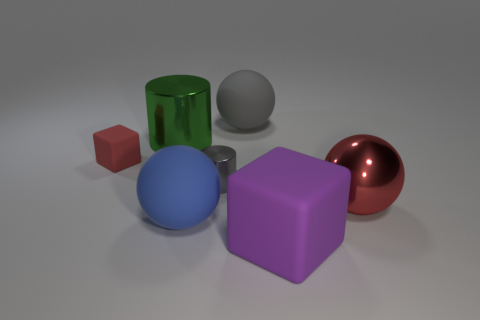Are there any gray spheres of the same size as the gray shiny cylinder?
Give a very brief answer. No. Is the material of the green object the same as the red object right of the purple thing?
Keep it short and to the point. Yes. Are there more purple rubber things than tiny cyan blocks?
Offer a very short reply. Yes. How many balls are big purple matte objects or large green shiny objects?
Provide a succinct answer. 0. The big cube has what color?
Ensure brevity in your answer.  Purple. Does the gray object behind the big green cylinder have the same size as the metal thing in front of the small cylinder?
Your response must be concise. Yes. Are there fewer blue rubber spheres than green matte cylinders?
Offer a terse response. No. What number of cylinders are in front of the tiny cube?
Offer a very short reply. 1. What is the material of the green thing?
Keep it short and to the point. Metal. Is the color of the small rubber cube the same as the metallic sphere?
Make the answer very short. Yes. 